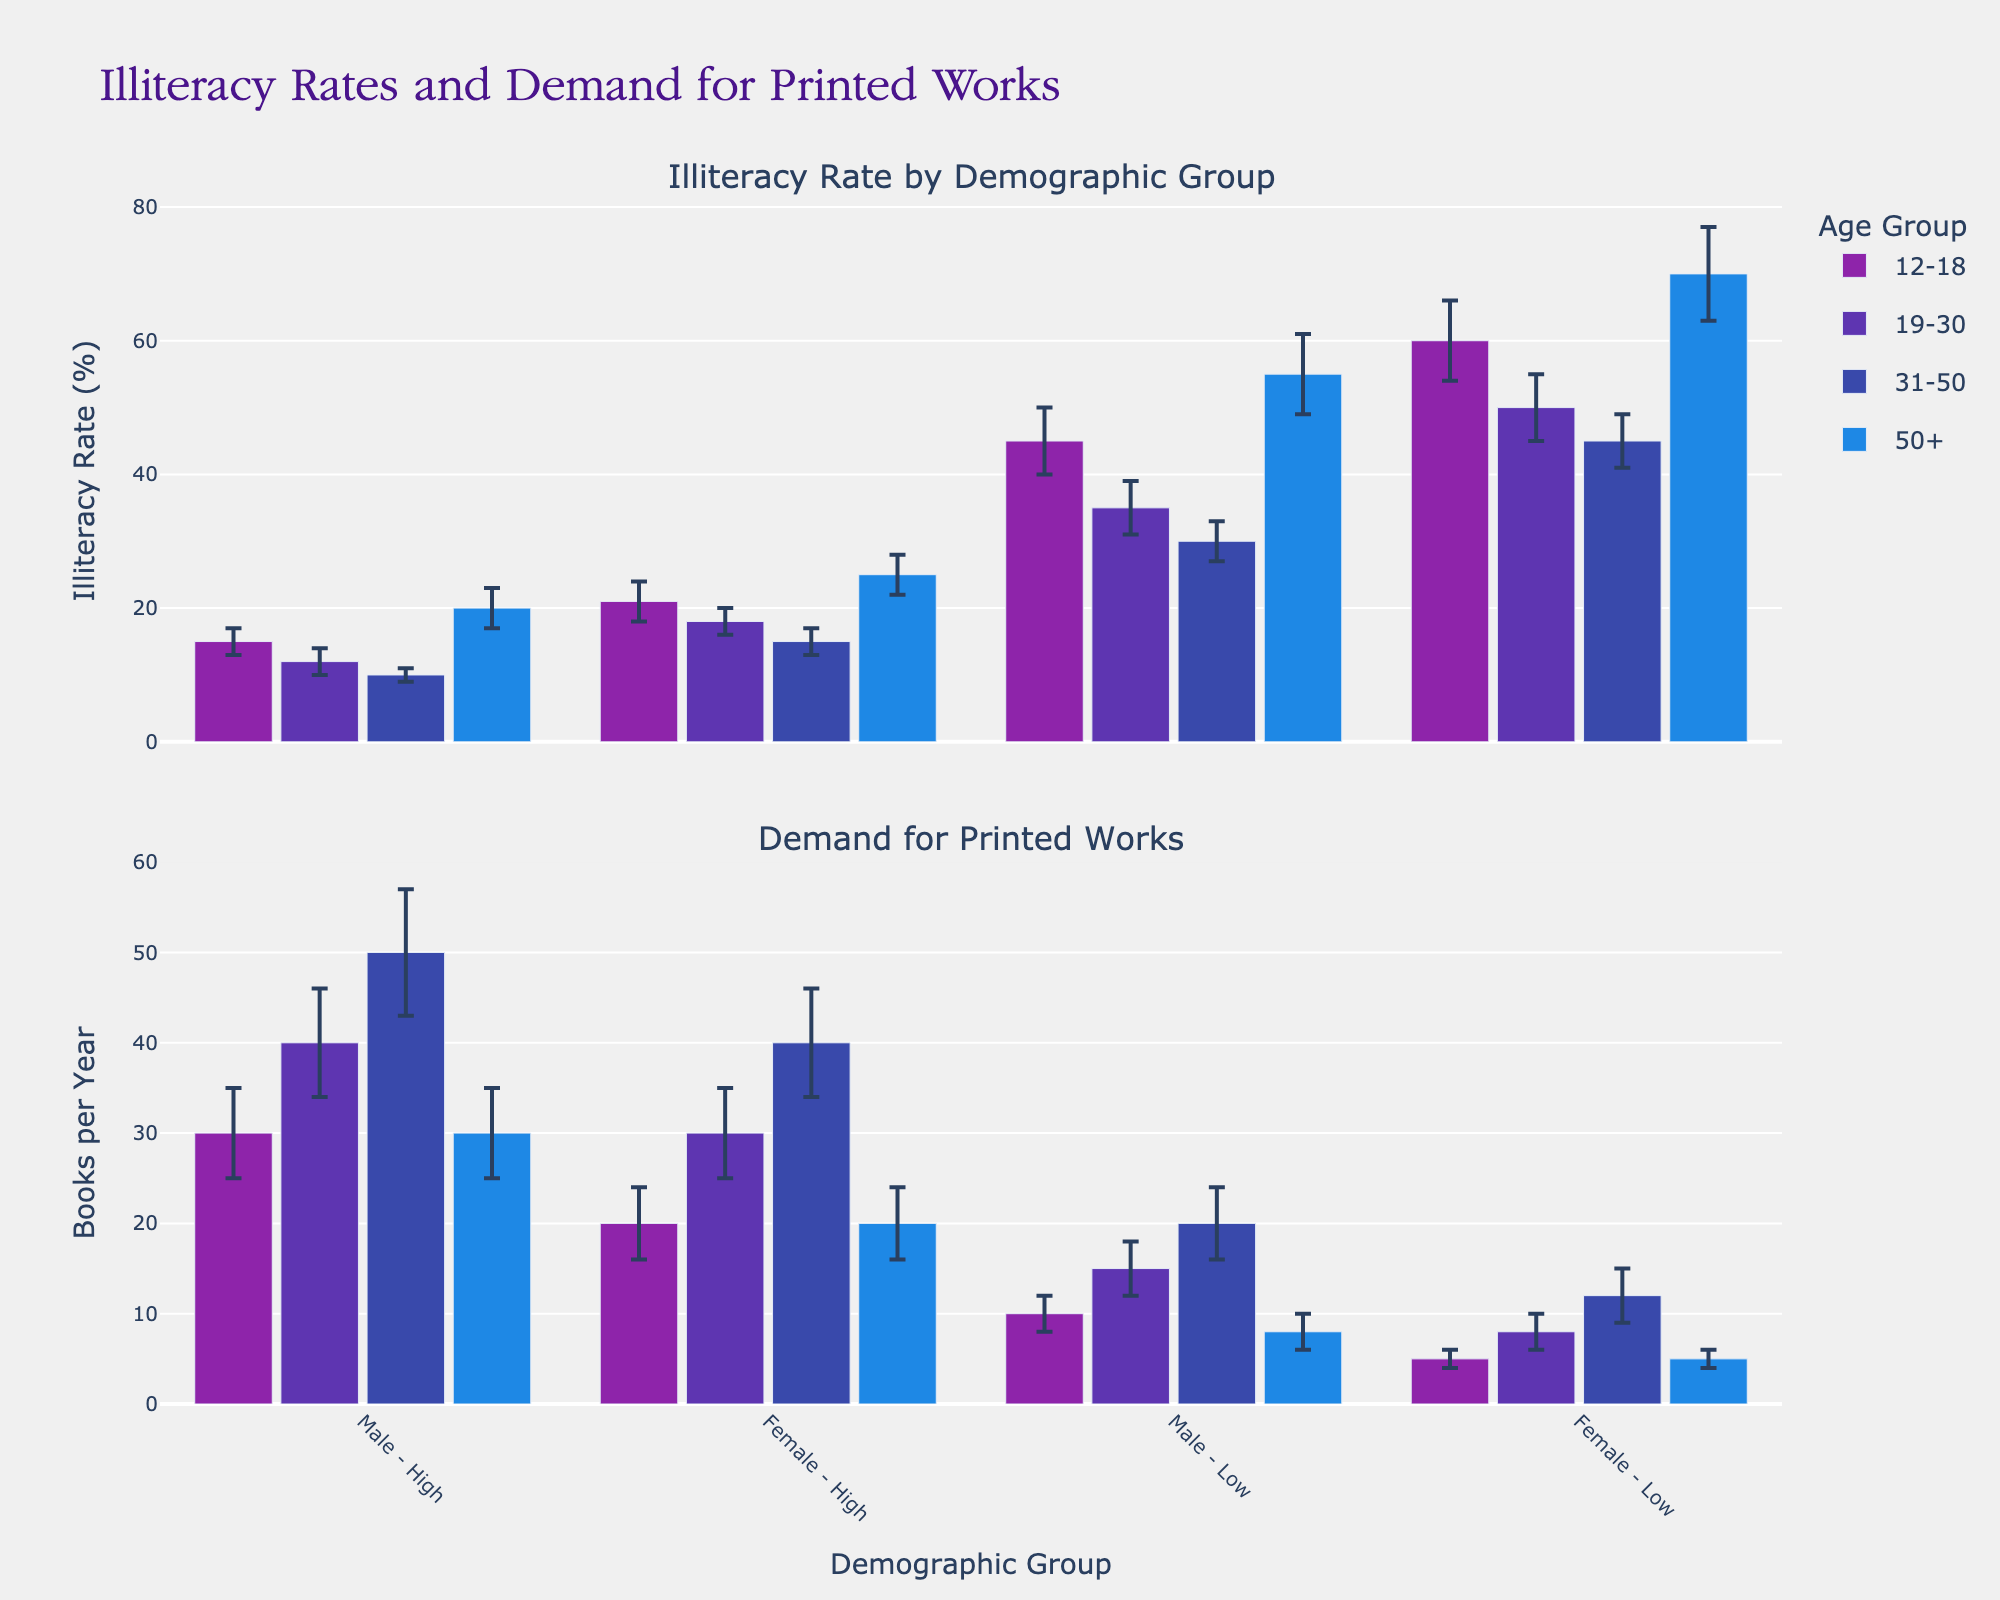What is the overall title of the figure? The title is prominently displayed at the top of the figure. It reads "Illiteracy Rates and Demand for Printed Works."
Answer: Illiteracy Rates and Demand for Printed Works What age group has the highest illiteracy rate for females in the low socioeconomic status? From the bars in the plot depicting illiteracy rates, it is evident that the age group 50+ has the highest illiteracy rate for females in the low socioeconomic status, with corresponding annotations indicating values.
Answer: 50+ How many demographic groups are plotted for each age group in the figure? Each age group in the figure has 4 demographic combinations displayed on the x-axis: Male-High, Female-High, Male-Low, and Female-Low. These combinations repeat for different age groups.
Answer: 4 Which age group has the highest demand for printed works among males in the high socioeconomic status? By examining the bars in the demand for printed works sub-plot, it is seen that the age group 31-50 has the highest demand for printed works among males in high socioeconomic status. This can be deduced from the tallest bar within that specific category.
Answer: 31-50 What is the difference in illiteracy rate between high socioeconomic status males aged 12-18 and those aged 19-30? The illiteracy rate for high socioeconomic status males aged 12-18 is 15%, and for those aged 19-30, it is 12%. The difference is obtained by subtracting 12 from 15.
Answer: 3% Which group shows the smallest margin of error in the demand for printed works? The bar plot for the demand for printed works shows error bars for each group. By comparing these, it's evident that females aged 12-18 in low socioeconomic status have the smallest margin of error, which is 1.
Answer: Females 12-18 Low Compare the illiteracy rate and demand for printed works for females aged 50+ in low socioeconomic status. The illiteracy rate for females aged 50+ in low socioeconomic status is 70%, while their demand for printed works is 5 books per year. The values can be directly read from their respective bars.
Answer: 70%, 5 books per year How does the demand for printed works for males aged 19-30 in low socioeconomic status compare to the demand for females aged 19-30 in high socioeconomic status? The demand for printed works for males aged 19-30 in low socioeconomic status is 15 books per year, while for females aged 19-30 in high socioeconomic status, it is 30 books per year. The comparison shows that females (high socioeconomic) demand more printed works than males (low socioeconomic).
Answer: Females 19-30 (high) have a higher demand What is the average illiteracy rate of all demographic groups for the age group 31-50? For the age group 31-50, the illiteracy rates are 10%, 15%, 30%, and 45%. To find the average, sum these values to get 100%, and then divide by the number of groups, which is 4.
Answer: 25% Which gender and socioeconomic status combination shows the highest variability in demand for printed works? The variability in demand can be assessed by looking at the length of error bars in the demand for printed works sub-plot. Males aged 31-50 in high socioeconomic status have the largest error margin (7 books per year), indicating the highest variability.
Answer: Males 31-50 High 